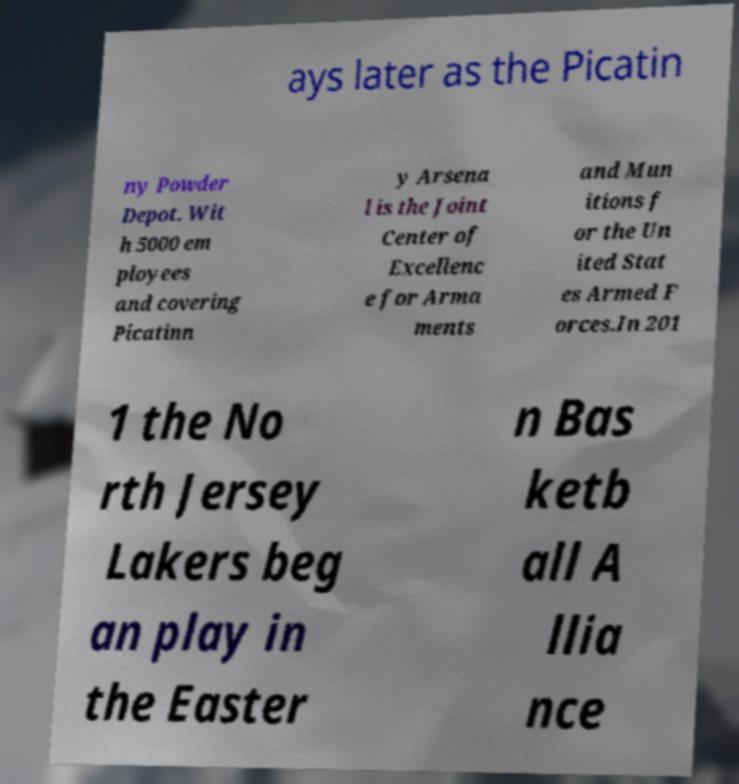Please identify and transcribe the text found in this image. ays later as the Picatin ny Powder Depot. Wit h 5000 em ployees and covering Picatinn y Arsena l is the Joint Center of Excellenc e for Arma ments and Mun itions f or the Un ited Stat es Armed F orces.In 201 1 the No rth Jersey Lakers beg an play in the Easter n Bas ketb all A llia nce 